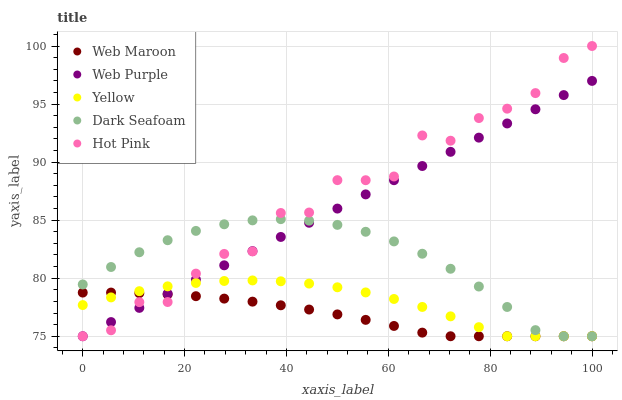Does Web Maroon have the minimum area under the curve?
Answer yes or no. Yes. Does Hot Pink have the maximum area under the curve?
Answer yes or no. Yes. Does Hot Pink have the minimum area under the curve?
Answer yes or no. No. Does Web Maroon have the maximum area under the curve?
Answer yes or no. No. Is Web Purple the smoothest?
Answer yes or no. Yes. Is Hot Pink the roughest?
Answer yes or no. Yes. Is Web Maroon the smoothest?
Answer yes or no. No. Is Web Maroon the roughest?
Answer yes or no. No. Does Web Purple have the lowest value?
Answer yes or no. Yes. Does Hot Pink have the highest value?
Answer yes or no. Yes. Does Web Maroon have the highest value?
Answer yes or no. No. Does Web Purple intersect Yellow?
Answer yes or no. Yes. Is Web Purple less than Yellow?
Answer yes or no. No. Is Web Purple greater than Yellow?
Answer yes or no. No. 